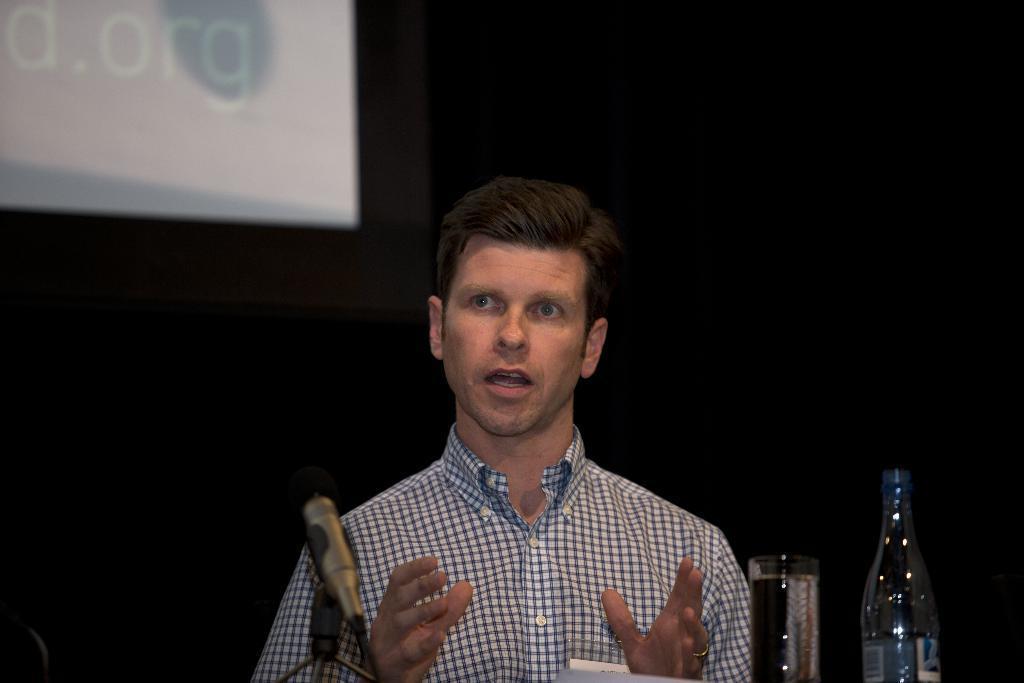Could you give a brief overview of what you see in this image? In the middle of the image we can see a man. In addition to this we can see a mic, a glass tumbler, a disposal bottle and a display behind the man. 